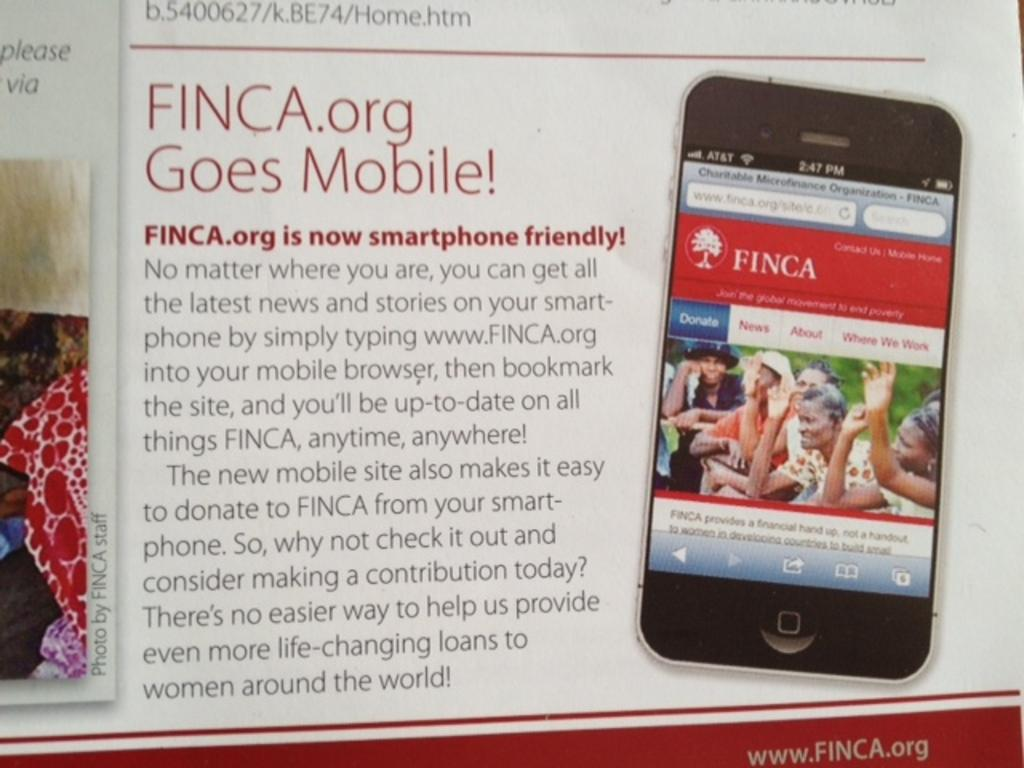Provide a one-sentence caption for the provided image. A poster shows that the FINCA.org website is now smartphone friendly. 